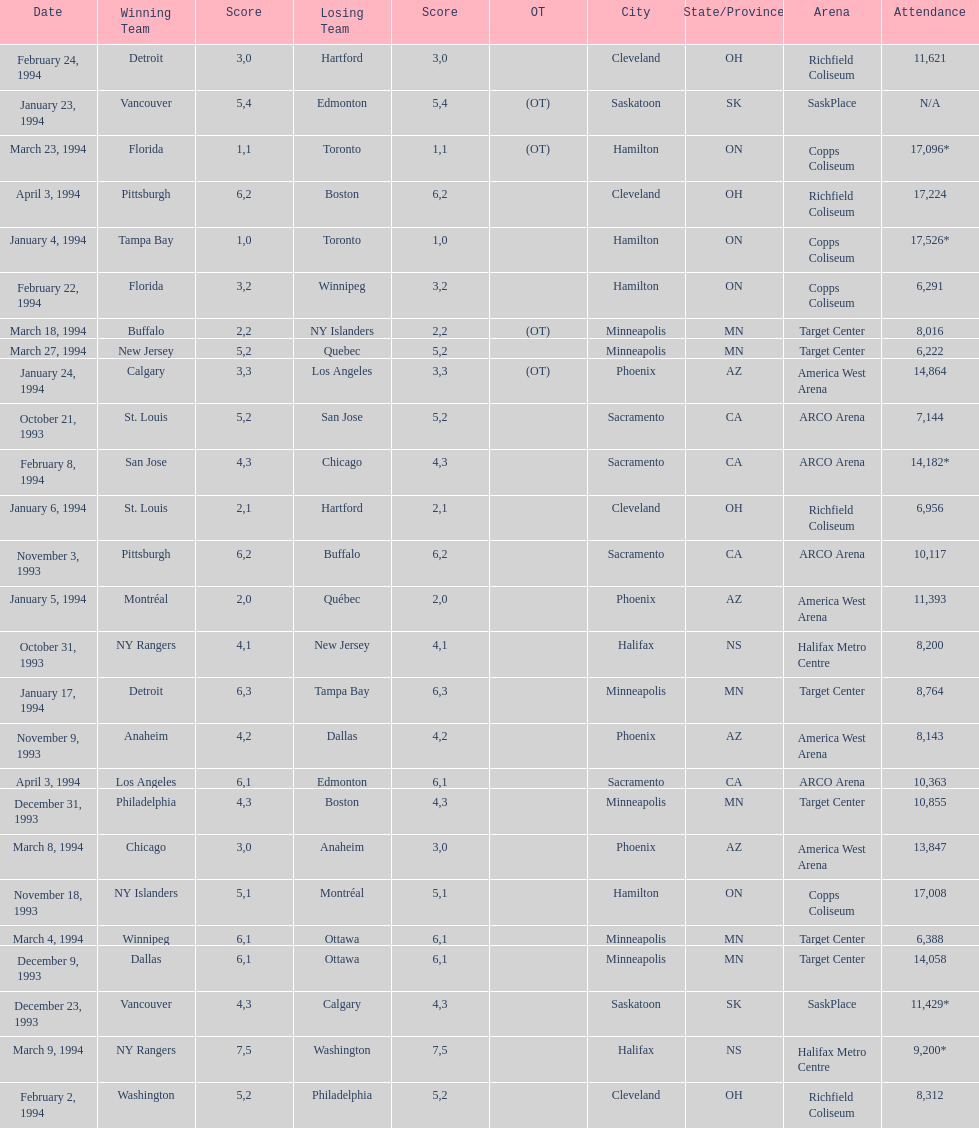Which occasion had greater presence, january 24, 1994, or december 23, 1993? January 4, 1994. 